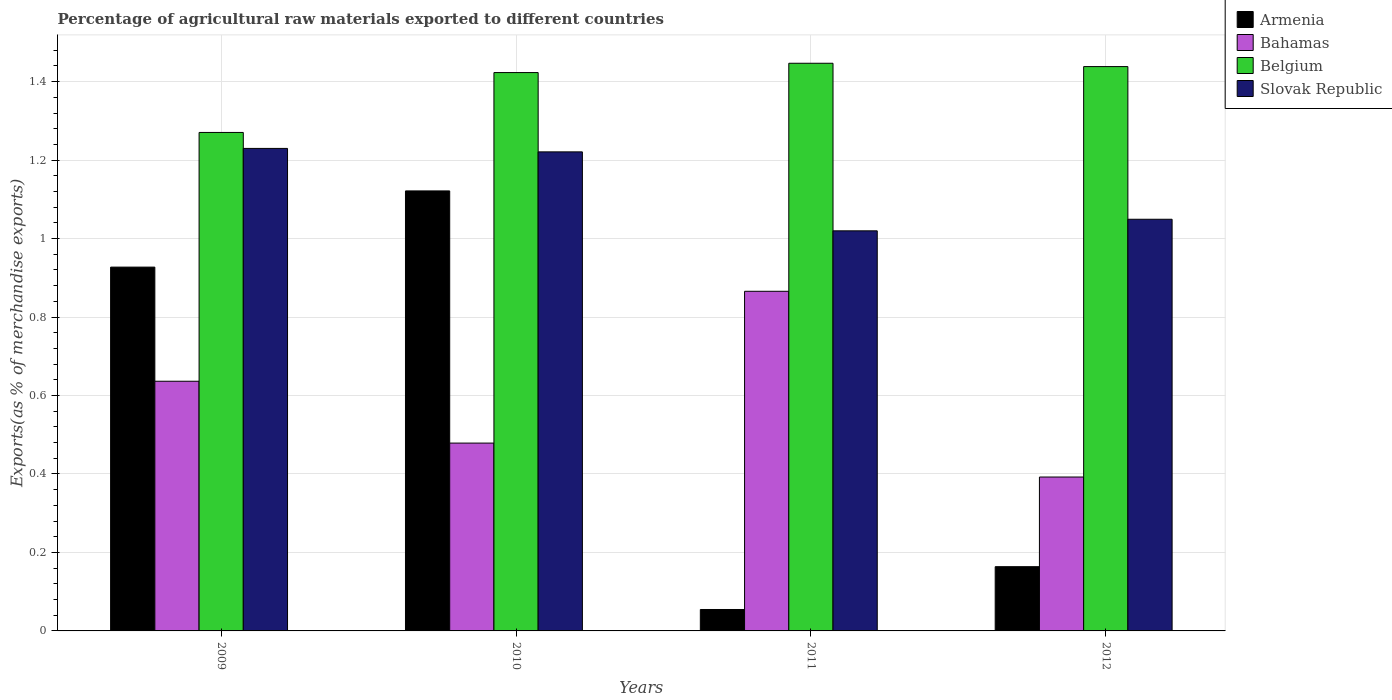How many different coloured bars are there?
Keep it short and to the point. 4. How many groups of bars are there?
Your answer should be very brief. 4. What is the label of the 4th group of bars from the left?
Ensure brevity in your answer.  2012. In how many cases, is the number of bars for a given year not equal to the number of legend labels?
Provide a succinct answer. 0. What is the percentage of exports to different countries in Bahamas in 2010?
Your answer should be compact. 0.48. Across all years, what is the maximum percentage of exports to different countries in Armenia?
Your response must be concise. 1.12. Across all years, what is the minimum percentage of exports to different countries in Bahamas?
Make the answer very short. 0.39. In which year was the percentage of exports to different countries in Bahamas maximum?
Keep it short and to the point. 2011. What is the total percentage of exports to different countries in Belgium in the graph?
Give a very brief answer. 5.58. What is the difference between the percentage of exports to different countries in Belgium in 2011 and that in 2012?
Ensure brevity in your answer.  0.01. What is the difference between the percentage of exports to different countries in Bahamas in 2011 and the percentage of exports to different countries in Armenia in 2010?
Your answer should be compact. -0.26. What is the average percentage of exports to different countries in Bahamas per year?
Offer a terse response. 0.59. In the year 2010, what is the difference between the percentage of exports to different countries in Belgium and percentage of exports to different countries in Armenia?
Your answer should be compact. 0.3. In how many years, is the percentage of exports to different countries in Bahamas greater than 0.48000000000000004 %?
Keep it short and to the point. 2. What is the ratio of the percentage of exports to different countries in Slovak Republic in 2010 to that in 2012?
Ensure brevity in your answer.  1.16. Is the difference between the percentage of exports to different countries in Belgium in 2009 and 2010 greater than the difference between the percentage of exports to different countries in Armenia in 2009 and 2010?
Give a very brief answer. Yes. What is the difference between the highest and the second highest percentage of exports to different countries in Bahamas?
Offer a very short reply. 0.23. What is the difference between the highest and the lowest percentage of exports to different countries in Bahamas?
Provide a succinct answer. 0.47. Is the sum of the percentage of exports to different countries in Armenia in 2009 and 2011 greater than the maximum percentage of exports to different countries in Belgium across all years?
Offer a terse response. No. Is it the case that in every year, the sum of the percentage of exports to different countries in Armenia and percentage of exports to different countries in Belgium is greater than the sum of percentage of exports to different countries in Slovak Republic and percentage of exports to different countries in Bahamas?
Give a very brief answer. No. What does the 1st bar from the left in 2009 represents?
Offer a very short reply. Armenia. What does the 4th bar from the right in 2010 represents?
Offer a terse response. Armenia. Is it the case that in every year, the sum of the percentage of exports to different countries in Belgium and percentage of exports to different countries in Bahamas is greater than the percentage of exports to different countries in Armenia?
Your answer should be compact. Yes. What is the difference between two consecutive major ticks on the Y-axis?
Offer a very short reply. 0.2. Are the values on the major ticks of Y-axis written in scientific E-notation?
Provide a succinct answer. No. How many legend labels are there?
Give a very brief answer. 4. How are the legend labels stacked?
Provide a short and direct response. Vertical. What is the title of the graph?
Your response must be concise. Percentage of agricultural raw materials exported to different countries. What is the label or title of the X-axis?
Give a very brief answer. Years. What is the label or title of the Y-axis?
Ensure brevity in your answer.  Exports(as % of merchandise exports). What is the Exports(as % of merchandise exports) in Armenia in 2009?
Your response must be concise. 0.93. What is the Exports(as % of merchandise exports) of Bahamas in 2009?
Ensure brevity in your answer.  0.64. What is the Exports(as % of merchandise exports) in Belgium in 2009?
Provide a short and direct response. 1.27. What is the Exports(as % of merchandise exports) of Slovak Republic in 2009?
Ensure brevity in your answer.  1.23. What is the Exports(as % of merchandise exports) of Armenia in 2010?
Your answer should be very brief. 1.12. What is the Exports(as % of merchandise exports) of Bahamas in 2010?
Offer a very short reply. 0.48. What is the Exports(as % of merchandise exports) in Belgium in 2010?
Make the answer very short. 1.42. What is the Exports(as % of merchandise exports) in Slovak Republic in 2010?
Offer a terse response. 1.22. What is the Exports(as % of merchandise exports) in Armenia in 2011?
Provide a short and direct response. 0.05. What is the Exports(as % of merchandise exports) of Bahamas in 2011?
Make the answer very short. 0.87. What is the Exports(as % of merchandise exports) of Belgium in 2011?
Make the answer very short. 1.45. What is the Exports(as % of merchandise exports) in Slovak Republic in 2011?
Offer a very short reply. 1.02. What is the Exports(as % of merchandise exports) of Armenia in 2012?
Ensure brevity in your answer.  0.16. What is the Exports(as % of merchandise exports) in Bahamas in 2012?
Your answer should be compact. 0.39. What is the Exports(as % of merchandise exports) in Belgium in 2012?
Your answer should be very brief. 1.44. What is the Exports(as % of merchandise exports) in Slovak Republic in 2012?
Provide a short and direct response. 1.05. Across all years, what is the maximum Exports(as % of merchandise exports) in Armenia?
Ensure brevity in your answer.  1.12. Across all years, what is the maximum Exports(as % of merchandise exports) in Bahamas?
Offer a very short reply. 0.87. Across all years, what is the maximum Exports(as % of merchandise exports) of Belgium?
Provide a succinct answer. 1.45. Across all years, what is the maximum Exports(as % of merchandise exports) in Slovak Republic?
Provide a short and direct response. 1.23. Across all years, what is the minimum Exports(as % of merchandise exports) of Armenia?
Offer a very short reply. 0.05. Across all years, what is the minimum Exports(as % of merchandise exports) of Bahamas?
Keep it short and to the point. 0.39. Across all years, what is the minimum Exports(as % of merchandise exports) of Belgium?
Your answer should be compact. 1.27. Across all years, what is the minimum Exports(as % of merchandise exports) in Slovak Republic?
Your answer should be very brief. 1.02. What is the total Exports(as % of merchandise exports) in Armenia in the graph?
Ensure brevity in your answer.  2.27. What is the total Exports(as % of merchandise exports) of Bahamas in the graph?
Offer a terse response. 2.37. What is the total Exports(as % of merchandise exports) in Belgium in the graph?
Offer a terse response. 5.58. What is the total Exports(as % of merchandise exports) of Slovak Republic in the graph?
Give a very brief answer. 4.52. What is the difference between the Exports(as % of merchandise exports) in Armenia in 2009 and that in 2010?
Keep it short and to the point. -0.19. What is the difference between the Exports(as % of merchandise exports) of Bahamas in 2009 and that in 2010?
Ensure brevity in your answer.  0.16. What is the difference between the Exports(as % of merchandise exports) of Belgium in 2009 and that in 2010?
Ensure brevity in your answer.  -0.15. What is the difference between the Exports(as % of merchandise exports) in Slovak Republic in 2009 and that in 2010?
Make the answer very short. 0.01. What is the difference between the Exports(as % of merchandise exports) of Armenia in 2009 and that in 2011?
Your response must be concise. 0.87. What is the difference between the Exports(as % of merchandise exports) of Bahamas in 2009 and that in 2011?
Your response must be concise. -0.23. What is the difference between the Exports(as % of merchandise exports) in Belgium in 2009 and that in 2011?
Give a very brief answer. -0.18. What is the difference between the Exports(as % of merchandise exports) in Slovak Republic in 2009 and that in 2011?
Provide a short and direct response. 0.21. What is the difference between the Exports(as % of merchandise exports) of Armenia in 2009 and that in 2012?
Offer a very short reply. 0.76. What is the difference between the Exports(as % of merchandise exports) of Bahamas in 2009 and that in 2012?
Give a very brief answer. 0.24. What is the difference between the Exports(as % of merchandise exports) in Belgium in 2009 and that in 2012?
Give a very brief answer. -0.17. What is the difference between the Exports(as % of merchandise exports) in Slovak Republic in 2009 and that in 2012?
Your answer should be very brief. 0.18. What is the difference between the Exports(as % of merchandise exports) of Armenia in 2010 and that in 2011?
Offer a terse response. 1.07. What is the difference between the Exports(as % of merchandise exports) of Bahamas in 2010 and that in 2011?
Offer a terse response. -0.39. What is the difference between the Exports(as % of merchandise exports) of Belgium in 2010 and that in 2011?
Give a very brief answer. -0.02. What is the difference between the Exports(as % of merchandise exports) of Slovak Republic in 2010 and that in 2011?
Your answer should be very brief. 0.2. What is the difference between the Exports(as % of merchandise exports) in Armenia in 2010 and that in 2012?
Your answer should be very brief. 0.96. What is the difference between the Exports(as % of merchandise exports) of Bahamas in 2010 and that in 2012?
Offer a terse response. 0.09. What is the difference between the Exports(as % of merchandise exports) in Belgium in 2010 and that in 2012?
Ensure brevity in your answer.  -0.02. What is the difference between the Exports(as % of merchandise exports) of Slovak Republic in 2010 and that in 2012?
Keep it short and to the point. 0.17. What is the difference between the Exports(as % of merchandise exports) in Armenia in 2011 and that in 2012?
Ensure brevity in your answer.  -0.11. What is the difference between the Exports(as % of merchandise exports) of Bahamas in 2011 and that in 2012?
Offer a very short reply. 0.47. What is the difference between the Exports(as % of merchandise exports) in Belgium in 2011 and that in 2012?
Offer a terse response. 0.01. What is the difference between the Exports(as % of merchandise exports) of Slovak Republic in 2011 and that in 2012?
Make the answer very short. -0.03. What is the difference between the Exports(as % of merchandise exports) in Armenia in 2009 and the Exports(as % of merchandise exports) in Bahamas in 2010?
Make the answer very short. 0.45. What is the difference between the Exports(as % of merchandise exports) in Armenia in 2009 and the Exports(as % of merchandise exports) in Belgium in 2010?
Provide a succinct answer. -0.5. What is the difference between the Exports(as % of merchandise exports) of Armenia in 2009 and the Exports(as % of merchandise exports) of Slovak Republic in 2010?
Your answer should be very brief. -0.29. What is the difference between the Exports(as % of merchandise exports) in Bahamas in 2009 and the Exports(as % of merchandise exports) in Belgium in 2010?
Give a very brief answer. -0.79. What is the difference between the Exports(as % of merchandise exports) in Bahamas in 2009 and the Exports(as % of merchandise exports) in Slovak Republic in 2010?
Offer a terse response. -0.58. What is the difference between the Exports(as % of merchandise exports) of Belgium in 2009 and the Exports(as % of merchandise exports) of Slovak Republic in 2010?
Provide a succinct answer. 0.05. What is the difference between the Exports(as % of merchandise exports) in Armenia in 2009 and the Exports(as % of merchandise exports) in Bahamas in 2011?
Give a very brief answer. 0.06. What is the difference between the Exports(as % of merchandise exports) of Armenia in 2009 and the Exports(as % of merchandise exports) of Belgium in 2011?
Give a very brief answer. -0.52. What is the difference between the Exports(as % of merchandise exports) in Armenia in 2009 and the Exports(as % of merchandise exports) in Slovak Republic in 2011?
Give a very brief answer. -0.09. What is the difference between the Exports(as % of merchandise exports) of Bahamas in 2009 and the Exports(as % of merchandise exports) of Belgium in 2011?
Ensure brevity in your answer.  -0.81. What is the difference between the Exports(as % of merchandise exports) of Bahamas in 2009 and the Exports(as % of merchandise exports) of Slovak Republic in 2011?
Your response must be concise. -0.38. What is the difference between the Exports(as % of merchandise exports) of Belgium in 2009 and the Exports(as % of merchandise exports) of Slovak Republic in 2011?
Make the answer very short. 0.25. What is the difference between the Exports(as % of merchandise exports) of Armenia in 2009 and the Exports(as % of merchandise exports) of Bahamas in 2012?
Offer a terse response. 0.54. What is the difference between the Exports(as % of merchandise exports) in Armenia in 2009 and the Exports(as % of merchandise exports) in Belgium in 2012?
Keep it short and to the point. -0.51. What is the difference between the Exports(as % of merchandise exports) in Armenia in 2009 and the Exports(as % of merchandise exports) in Slovak Republic in 2012?
Offer a very short reply. -0.12. What is the difference between the Exports(as % of merchandise exports) in Bahamas in 2009 and the Exports(as % of merchandise exports) in Belgium in 2012?
Your answer should be very brief. -0.8. What is the difference between the Exports(as % of merchandise exports) in Bahamas in 2009 and the Exports(as % of merchandise exports) in Slovak Republic in 2012?
Offer a terse response. -0.41. What is the difference between the Exports(as % of merchandise exports) in Belgium in 2009 and the Exports(as % of merchandise exports) in Slovak Republic in 2012?
Your answer should be very brief. 0.22. What is the difference between the Exports(as % of merchandise exports) in Armenia in 2010 and the Exports(as % of merchandise exports) in Bahamas in 2011?
Ensure brevity in your answer.  0.26. What is the difference between the Exports(as % of merchandise exports) in Armenia in 2010 and the Exports(as % of merchandise exports) in Belgium in 2011?
Provide a short and direct response. -0.33. What is the difference between the Exports(as % of merchandise exports) in Armenia in 2010 and the Exports(as % of merchandise exports) in Slovak Republic in 2011?
Your answer should be compact. 0.1. What is the difference between the Exports(as % of merchandise exports) of Bahamas in 2010 and the Exports(as % of merchandise exports) of Belgium in 2011?
Offer a very short reply. -0.97. What is the difference between the Exports(as % of merchandise exports) of Bahamas in 2010 and the Exports(as % of merchandise exports) of Slovak Republic in 2011?
Your answer should be very brief. -0.54. What is the difference between the Exports(as % of merchandise exports) of Belgium in 2010 and the Exports(as % of merchandise exports) of Slovak Republic in 2011?
Give a very brief answer. 0.4. What is the difference between the Exports(as % of merchandise exports) in Armenia in 2010 and the Exports(as % of merchandise exports) in Bahamas in 2012?
Your response must be concise. 0.73. What is the difference between the Exports(as % of merchandise exports) in Armenia in 2010 and the Exports(as % of merchandise exports) in Belgium in 2012?
Offer a terse response. -0.32. What is the difference between the Exports(as % of merchandise exports) in Armenia in 2010 and the Exports(as % of merchandise exports) in Slovak Republic in 2012?
Provide a short and direct response. 0.07. What is the difference between the Exports(as % of merchandise exports) in Bahamas in 2010 and the Exports(as % of merchandise exports) in Belgium in 2012?
Your response must be concise. -0.96. What is the difference between the Exports(as % of merchandise exports) in Bahamas in 2010 and the Exports(as % of merchandise exports) in Slovak Republic in 2012?
Ensure brevity in your answer.  -0.57. What is the difference between the Exports(as % of merchandise exports) in Belgium in 2010 and the Exports(as % of merchandise exports) in Slovak Republic in 2012?
Offer a terse response. 0.37. What is the difference between the Exports(as % of merchandise exports) of Armenia in 2011 and the Exports(as % of merchandise exports) of Bahamas in 2012?
Keep it short and to the point. -0.34. What is the difference between the Exports(as % of merchandise exports) of Armenia in 2011 and the Exports(as % of merchandise exports) of Belgium in 2012?
Ensure brevity in your answer.  -1.38. What is the difference between the Exports(as % of merchandise exports) of Armenia in 2011 and the Exports(as % of merchandise exports) of Slovak Republic in 2012?
Provide a short and direct response. -0.99. What is the difference between the Exports(as % of merchandise exports) of Bahamas in 2011 and the Exports(as % of merchandise exports) of Belgium in 2012?
Ensure brevity in your answer.  -0.57. What is the difference between the Exports(as % of merchandise exports) of Bahamas in 2011 and the Exports(as % of merchandise exports) of Slovak Republic in 2012?
Offer a terse response. -0.18. What is the difference between the Exports(as % of merchandise exports) in Belgium in 2011 and the Exports(as % of merchandise exports) in Slovak Republic in 2012?
Your response must be concise. 0.4. What is the average Exports(as % of merchandise exports) in Armenia per year?
Your response must be concise. 0.57. What is the average Exports(as % of merchandise exports) in Bahamas per year?
Your response must be concise. 0.59. What is the average Exports(as % of merchandise exports) of Belgium per year?
Provide a succinct answer. 1.39. What is the average Exports(as % of merchandise exports) of Slovak Republic per year?
Offer a very short reply. 1.13. In the year 2009, what is the difference between the Exports(as % of merchandise exports) of Armenia and Exports(as % of merchandise exports) of Bahamas?
Your response must be concise. 0.29. In the year 2009, what is the difference between the Exports(as % of merchandise exports) of Armenia and Exports(as % of merchandise exports) of Belgium?
Your response must be concise. -0.34. In the year 2009, what is the difference between the Exports(as % of merchandise exports) in Armenia and Exports(as % of merchandise exports) in Slovak Republic?
Your response must be concise. -0.3. In the year 2009, what is the difference between the Exports(as % of merchandise exports) in Bahamas and Exports(as % of merchandise exports) in Belgium?
Ensure brevity in your answer.  -0.63. In the year 2009, what is the difference between the Exports(as % of merchandise exports) in Bahamas and Exports(as % of merchandise exports) in Slovak Republic?
Your answer should be very brief. -0.59. In the year 2009, what is the difference between the Exports(as % of merchandise exports) of Belgium and Exports(as % of merchandise exports) of Slovak Republic?
Make the answer very short. 0.04. In the year 2010, what is the difference between the Exports(as % of merchandise exports) in Armenia and Exports(as % of merchandise exports) in Bahamas?
Provide a short and direct response. 0.64. In the year 2010, what is the difference between the Exports(as % of merchandise exports) in Armenia and Exports(as % of merchandise exports) in Belgium?
Give a very brief answer. -0.3. In the year 2010, what is the difference between the Exports(as % of merchandise exports) of Armenia and Exports(as % of merchandise exports) of Slovak Republic?
Offer a very short reply. -0.1. In the year 2010, what is the difference between the Exports(as % of merchandise exports) in Bahamas and Exports(as % of merchandise exports) in Belgium?
Give a very brief answer. -0.94. In the year 2010, what is the difference between the Exports(as % of merchandise exports) in Bahamas and Exports(as % of merchandise exports) in Slovak Republic?
Keep it short and to the point. -0.74. In the year 2010, what is the difference between the Exports(as % of merchandise exports) in Belgium and Exports(as % of merchandise exports) in Slovak Republic?
Provide a succinct answer. 0.2. In the year 2011, what is the difference between the Exports(as % of merchandise exports) in Armenia and Exports(as % of merchandise exports) in Bahamas?
Your response must be concise. -0.81. In the year 2011, what is the difference between the Exports(as % of merchandise exports) of Armenia and Exports(as % of merchandise exports) of Belgium?
Your answer should be compact. -1.39. In the year 2011, what is the difference between the Exports(as % of merchandise exports) in Armenia and Exports(as % of merchandise exports) in Slovak Republic?
Provide a succinct answer. -0.97. In the year 2011, what is the difference between the Exports(as % of merchandise exports) of Bahamas and Exports(as % of merchandise exports) of Belgium?
Ensure brevity in your answer.  -0.58. In the year 2011, what is the difference between the Exports(as % of merchandise exports) in Bahamas and Exports(as % of merchandise exports) in Slovak Republic?
Your answer should be compact. -0.15. In the year 2011, what is the difference between the Exports(as % of merchandise exports) of Belgium and Exports(as % of merchandise exports) of Slovak Republic?
Provide a short and direct response. 0.43. In the year 2012, what is the difference between the Exports(as % of merchandise exports) in Armenia and Exports(as % of merchandise exports) in Bahamas?
Offer a terse response. -0.23. In the year 2012, what is the difference between the Exports(as % of merchandise exports) in Armenia and Exports(as % of merchandise exports) in Belgium?
Provide a short and direct response. -1.27. In the year 2012, what is the difference between the Exports(as % of merchandise exports) of Armenia and Exports(as % of merchandise exports) of Slovak Republic?
Offer a very short reply. -0.89. In the year 2012, what is the difference between the Exports(as % of merchandise exports) in Bahamas and Exports(as % of merchandise exports) in Belgium?
Offer a terse response. -1.05. In the year 2012, what is the difference between the Exports(as % of merchandise exports) in Bahamas and Exports(as % of merchandise exports) in Slovak Republic?
Give a very brief answer. -0.66. In the year 2012, what is the difference between the Exports(as % of merchandise exports) of Belgium and Exports(as % of merchandise exports) of Slovak Republic?
Offer a terse response. 0.39. What is the ratio of the Exports(as % of merchandise exports) of Armenia in 2009 to that in 2010?
Your response must be concise. 0.83. What is the ratio of the Exports(as % of merchandise exports) of Bahamas in 2009 to that in 2010?
Provide a short and direct response. 1.33. What is the ratio of the Exports(as % of merchandise exports) of Belgium in 2009 to that in 2010?
Your answer should be very brief. 0.89. What is the ratio of the Exports(as % of merchandise exports) of Slovak Republic in 2009 to that in 2010?
Offer a terse response. 1.01. What is the ratio of the Exports(as % of merchandise exports) in Armenia in 2009 to that in 2011?
Make the answer very short. 16.97. What is the ratio of the Exports(as % of merchandise exports) of Bahamas in 2009 to that in 2011?
Ensure brevity in your answer.  0.74. What is the ratio of the Exports(as % of merchandise exports) in Belgium in 2009 to that in 2011?
Your answer should be very brief. 0.88. What is the ratio of the Exports(as % of merchandise exports) of Slovak Republic in 2009 to that in 2011?
Offer a very short reply. 1.21. What is the ratio of the Exports(as % of merchandise exports) in Armenia in 2009 to that in 2012?
Offer a very short reply. 5.66. What is the ratio of the Exports(as % of merchandise exports) of Bahamas in 2009 to that in 2012?
Provide a succinct answer. 1.62. What is the ratio of the Exports(as % of merchandise exports) in Belgium in 2009 to that in 2012?
Give a very brief answer. 0.88. What is the ratio of the Exports(as % of merchandise exports) of Slovak Republic in 2009 to that in 2012?
Your answer should be compact. 1.17. What is the ratio of the Exports(as % of merchandise exports) of Armenia in 2010 to that in 2011?
Provide a short and direct response. 20.53. What is the ratio of the Exports(as % of merchandise exports) of Bahamas in 2010 to that in 2011?
Keep it short and to the point. 0.55. What is the ratio of the Exports(as % of merchandise exports) in Belgium in 2010 to that in 2011?
Offer a very short reply. 0.98. What is the ratio of the Exports(as % of merchandise exports) in Slovak Republic in 2010 to that in 2011?
Make the answer very short. 1.2. What is the ratio of the Exports(as % of merchandise exports) in Armenia in 2010 to that in 2012?
Keep it short and to the point. 6.85. What is the ratio of the Exports(as % of merchandise exports) in Bahamas in 2010 to that in 2012?
Offer a terse response. 1.22. What is the ratio of the Exports(as % of merchandise exports) of Belgium in 2010 to that in 2012?
Your answer should be compact. 0.99. What is the ratio of the Exports(as % of merchandise exports) in Slovak Republic in 2010 to that in 2012?
Offer a very short reply. 1.16. What is the ratio of the Exports(as % of merchandise exports) in Armenia in 2011 to that in 2012?
Offer a very short reply. 0.33. What is the ratio of the Exports(as % of merchandise exports) in Bahamas in 2011 to that in 2012?
Your answer should be very brief. 2.21. What is the ratio of the Exports(as % of merchandise exports) in Belgium in 2011 to that in 2012?
Your response must be concise. 1.01. What is the ratio of the Exports(as % of merchandise exports) in Slovak Republic in 2011 to that in 2012?
Offer a terse response. 0.97. What is the difference between the highest and the second highest Exports(as % of merchandise exports) of Armenia?
Make the answer very short. 0.19. What is the difference between the highest and the second highest Exports(as % of merchandise exports) in Bahamas?
Provide a succinct answer. 0.23. What is the difference between the highest and the second highest Exports(as % of merchandise exports) in Belgium?
Ensure brevity in your answer.  0.01. What is the difference between the highest and the second highest Exports(as % of merchandise exports) in Slovak Republic?
Your response must be concise. 0.01. What is the difference between the highest and the lowest Exports(as % of merchandise exports) in Armenia?
Keep it short and to the point. 1.07. What is the difference between the highest and the lowest Exports(as % of merchandise exports) in Bahamas?
Your answer should be very brief. 0.47. What is the difference between the highest and the lowest Exports(as % of merchandise exports) of Belgium?
Provide a succinct answer. 0.18. What is the difference between the highest and the lowest Exports(as % of merchandise exports) of Slovak Republic?
Offer a terse response. 0.21. 